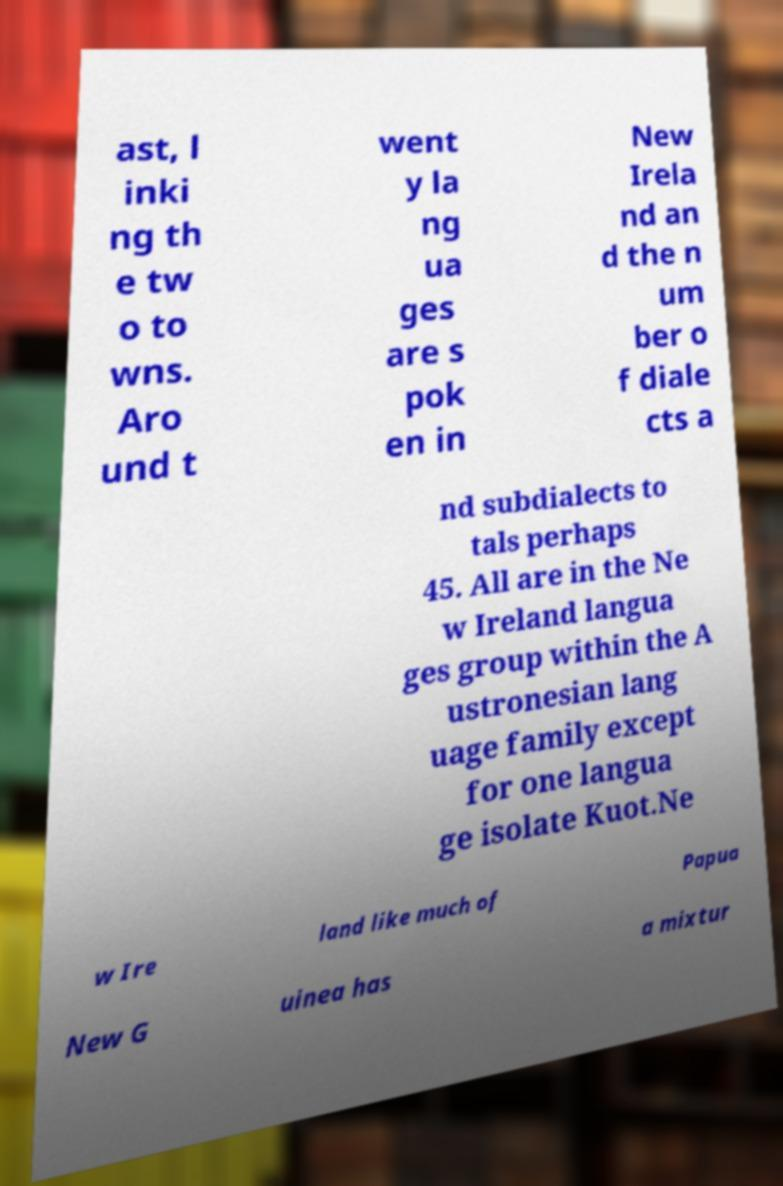Can you accurately transcribe the text from the provided image for me? ast, l inki ng th e tw o to wns. Aro und t went y la ng ua ges are s pok en in New Irela nd an d the n um ber o f diale cts a nd subdialects to tals perhaps 45. All are in the Ne w Ireland langua ges group within the A ustronesian lang uage family except for one langua ge isolate Kuot.Ne w Ire land like much of Papua New G uinea has a mixtur 